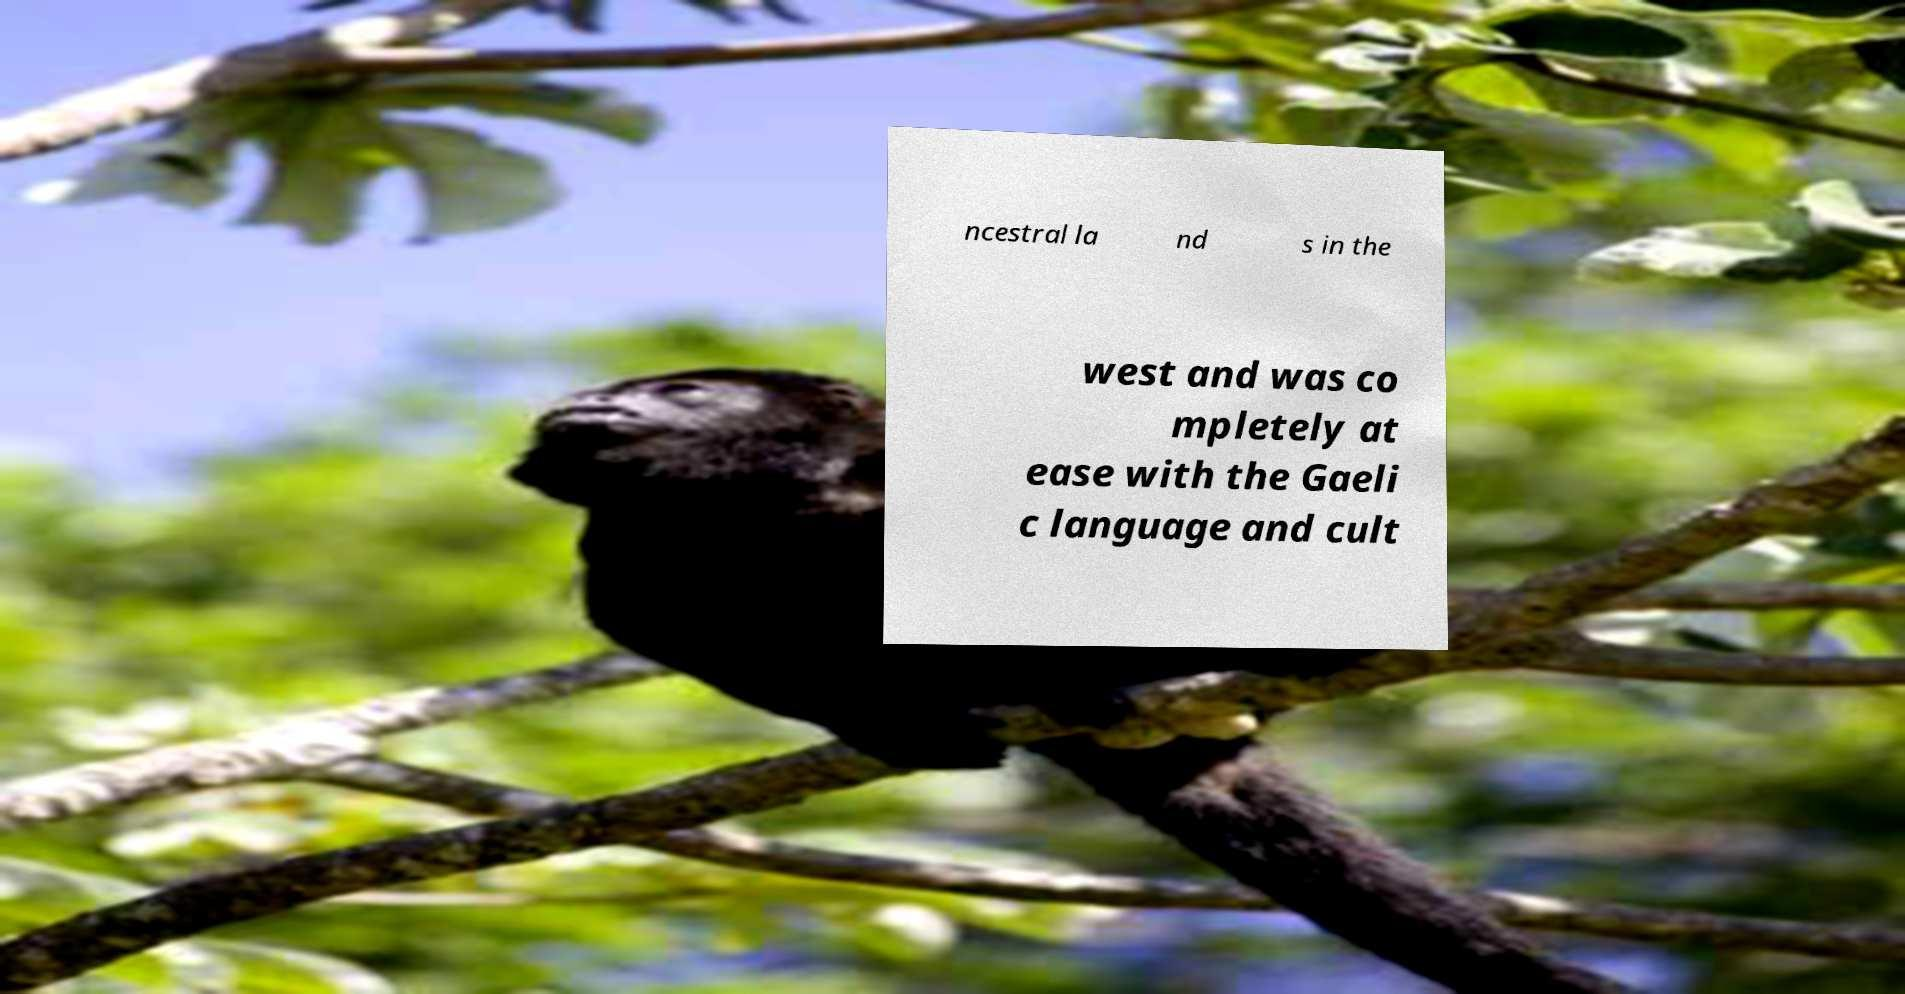I need the written content from this picture converted into text. Can you do that? ncestral la nd s in the west and was co mpletely at ease with the Gaeli c language and cult 